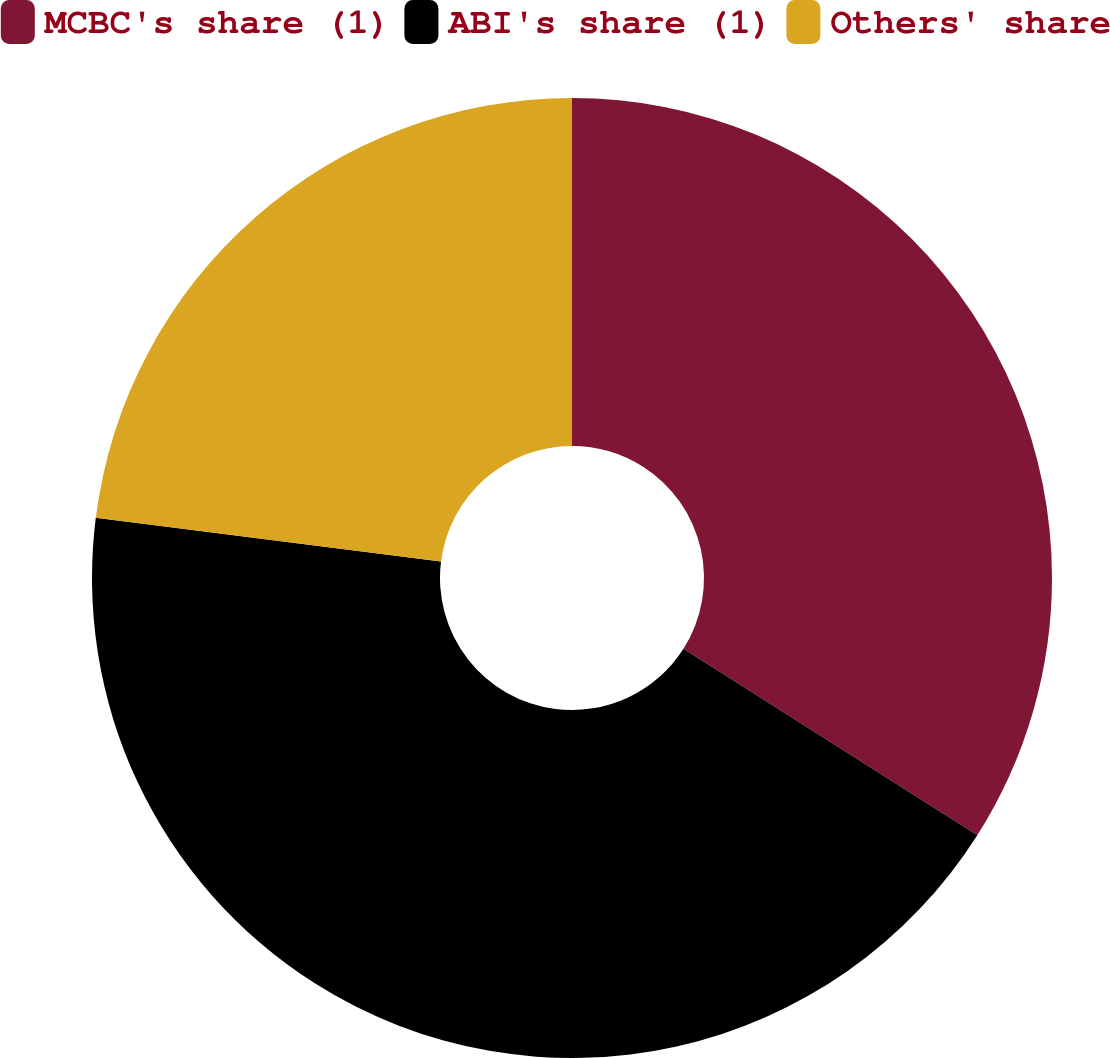Convert chart to OTSL. <chart><loc_0><loc_0><loc_500><loc_500><pie_chart><fcel>MCBC's share (1)<fcel>ABI's share (1)<fcel>Others' share<nl><fcel>34.0%<fcel>43.0%<fcel>23.0%<nl></chart> 